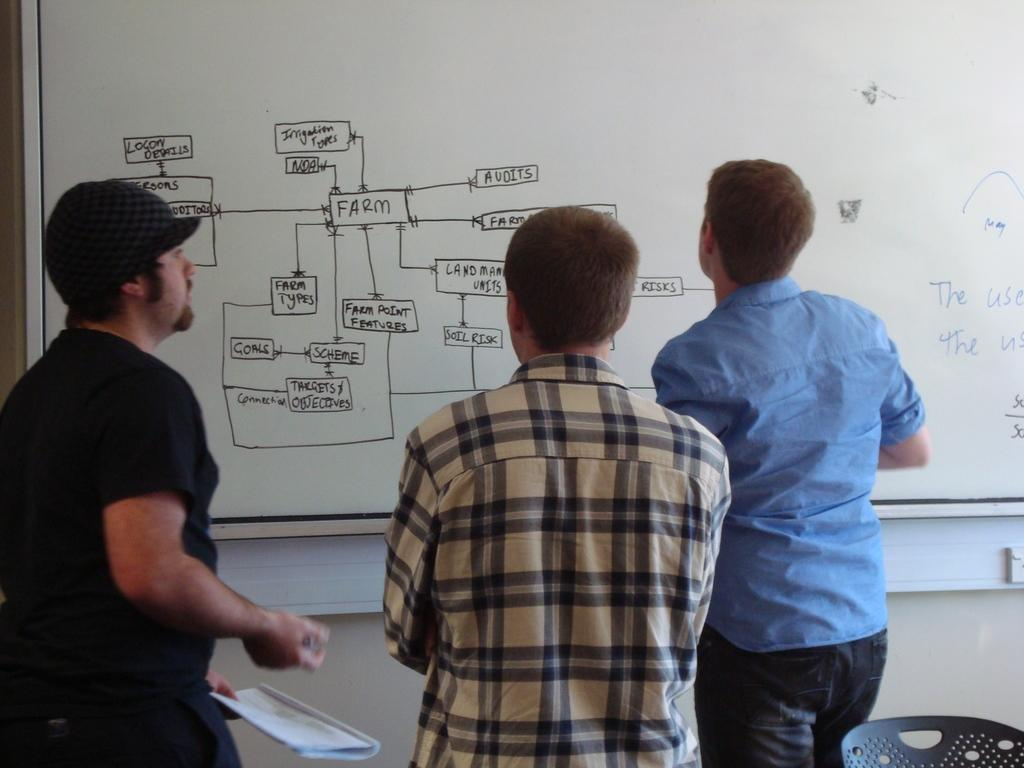<image>
Relay a brief, clear account of the picture shown. Three people are looking at a flow chart that includes a box that says "farm types." 